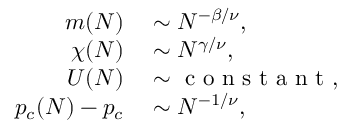Convert formula to latex. <formula><loc_0><loc_0><loc_500><loc_500>\begin{array} { r l } { m ( N ) } & \sim N ^ { - \beta / \nu } , } \\ { \chi ( N ) } & \sim N ^ { \gamma / \nu } , } \\ { U ( N ) } & \sim c o n s t a n t , } \\ { p _ { c } ( N ) - p _ { c } } & \sim N ^ { - 1 / \nu } , } \end{array}</formula> 